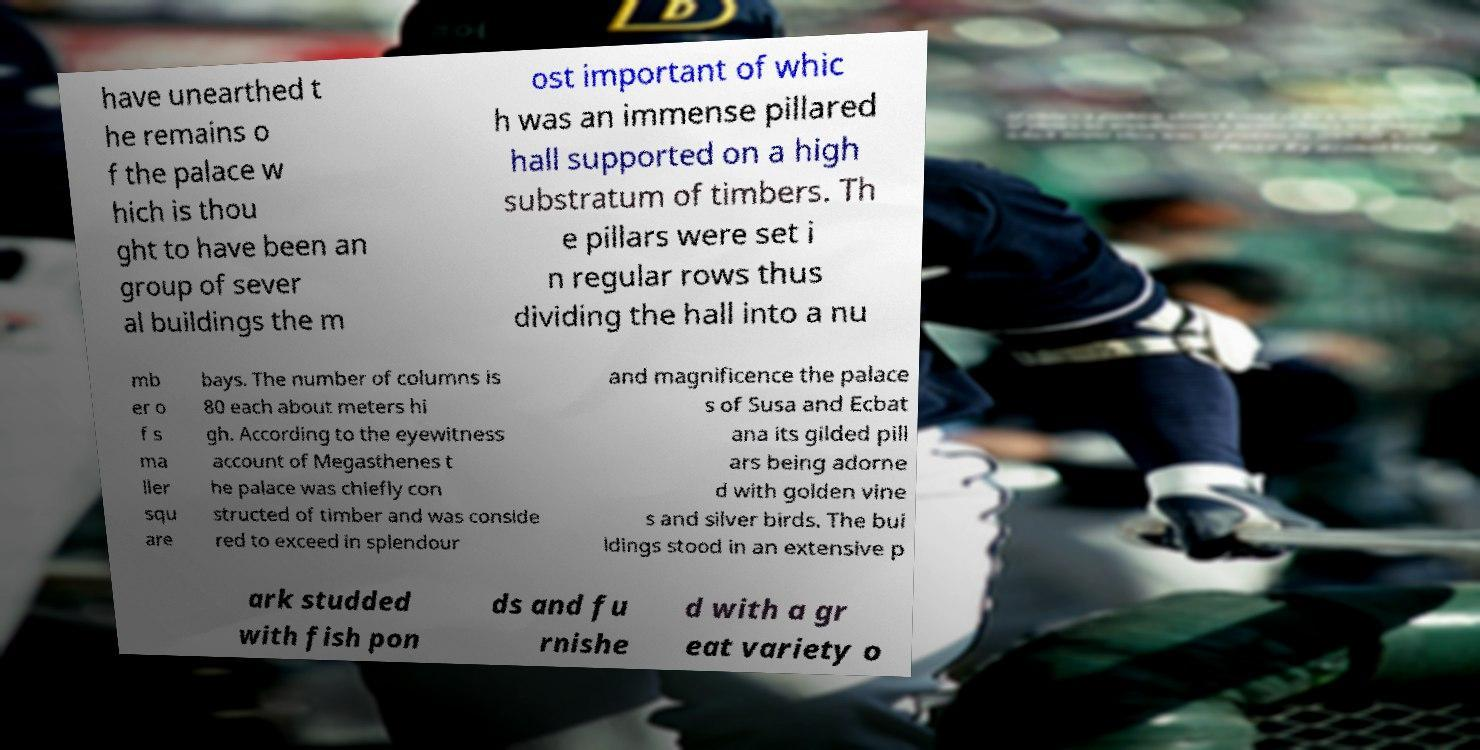Please read and relay the text visible in this image. What does it say? have unearthed t he remains o f the palace w hich is thou ght to have been an group of sever al buildings the m ost important of whic h was an immense pillared hall supported on a high substratum of timbers. Th e pillars were set i n regular rows thus dividing the hall into a nu mb er o f s ma ller squ are bays. The number of columns is 80 each about meters hi gh. According to the eyewitness account of Megasthenes t he palace was chiefly con structed of timber and was conside red to exceed in splendour and magnificence the palace s of Susa and Ecbat ana its gilded pill ars being adorne d with golden vine s and silver birds. The bui ldings stood in an extensive p ark studded with fish pon ds and fu rnishe d with a gr eat variety o 